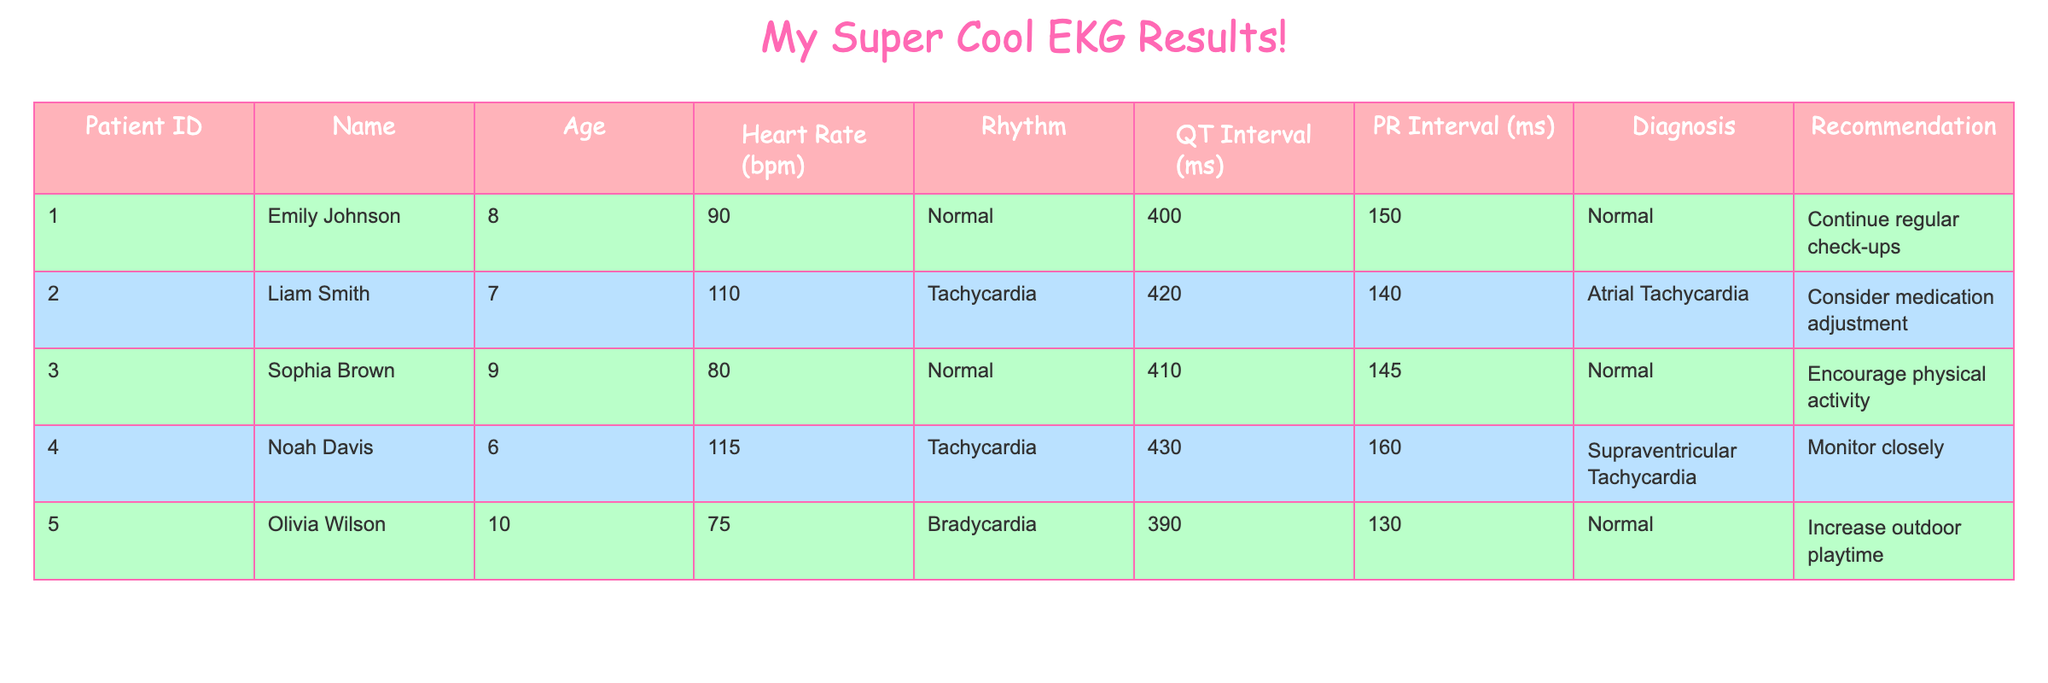What is the heart rate of Emily Johnson? Emily Johnson's heart rate is listed in the table under the "Heart Rate (bpm)" column, which shows a value of 90.
Answer: 90 bpm Which patient has the longest QT interval? By looking through the "QT Interval (ms)" column, the highest value is 430 ms, associated with Noah Davis.
Answer: Noah Davis How many patients have a normal rhythm? The "Rhythm" column indicates that both Emily Johnson and Sophia Brown have a "Normal" rhythm. There are two instances of "Normal" rhythm, leading to the conclusion that two patients have this rhythm.
Answer: 2 What is the average heart rate of all patients? To find the average heart rate, we sum the heart rates: 90 + 110 + 80 + 115 + 75 = 570. Then, dividing 570 by the number of patients (5) gives an average heart rate of 114.
Answer: 114 bpm Is there any patient who has a diagnosis of bradycardia? Looking through the "Diagnosis" column, Olivia Wilson is listed with "Bradycardia," confirming there is at least one patient with this diagnosis.
Answer: Yes What is the recommendation for the patient diagnosed with Supraventricular Tachycardia? The table indicates that Noah Davis, diagnosed with Supraventricular Tachycardia, has a recommendation to "Monitor closely," which is found in the "Recommendation" column.
Answer: Monitor closely Which patient has the lowest heart rate, and what is it? To find the patient with the lowest heart rate, we review the "Heart Rate (bpm)" column. Olivia Wilson has the lowest heart rate at 75 bpm.
Answer: Olivia Wilson, 75 bpm What is the difference between the QT interval of Liam Smith and that of Sophia Brown? Liam Smith's QT interval is 420 ms, and Sophia Brown's is 410 ms. Calculating the difference gives us 420 - 410 = 10 ms.
Answer: 10 ms How many patients have a recommendation to increase outdoor playtime? The "Recommendation" for Olivia Wilson states "Increase outdoor playtime," indicating there is only one patient with this specific recommendation.
Answer: 1 